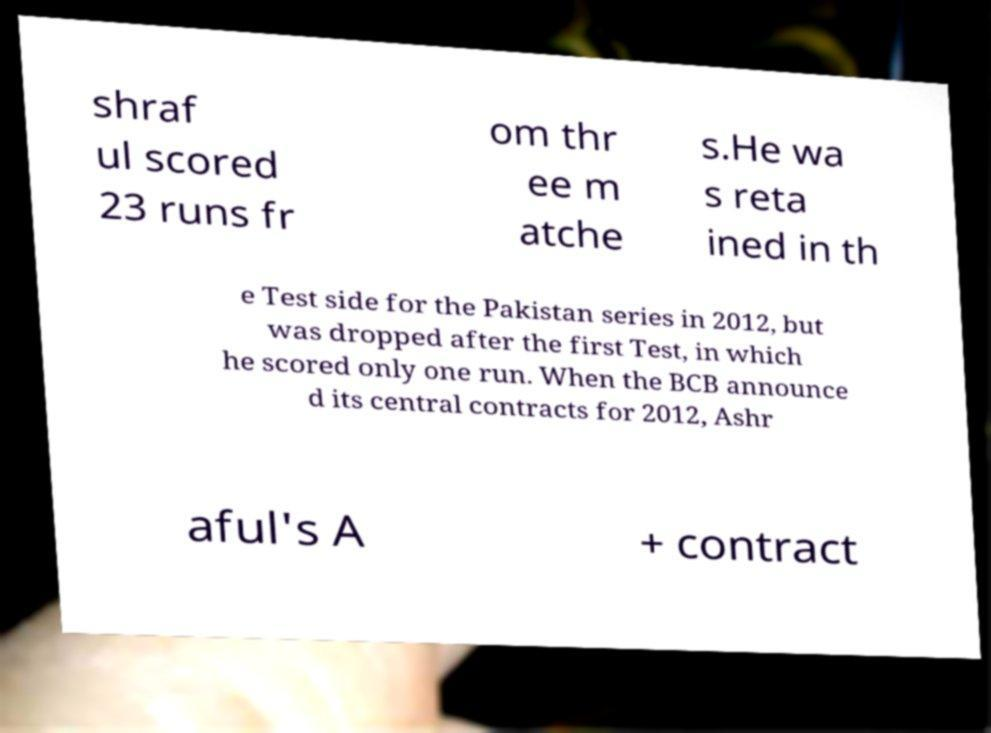There's text embedded in this image that I need extracted. Can you transcribe it verbatim? shraf ul scored 23 runs fr om thr ee m atche s.He wa s reta ined in th e Test side for the Pakistan series in 2012, but was dropped after the first Test, in which he scored only one run. When the BCB announce d its central contracts for 2012, Ashr aful's A + contract 